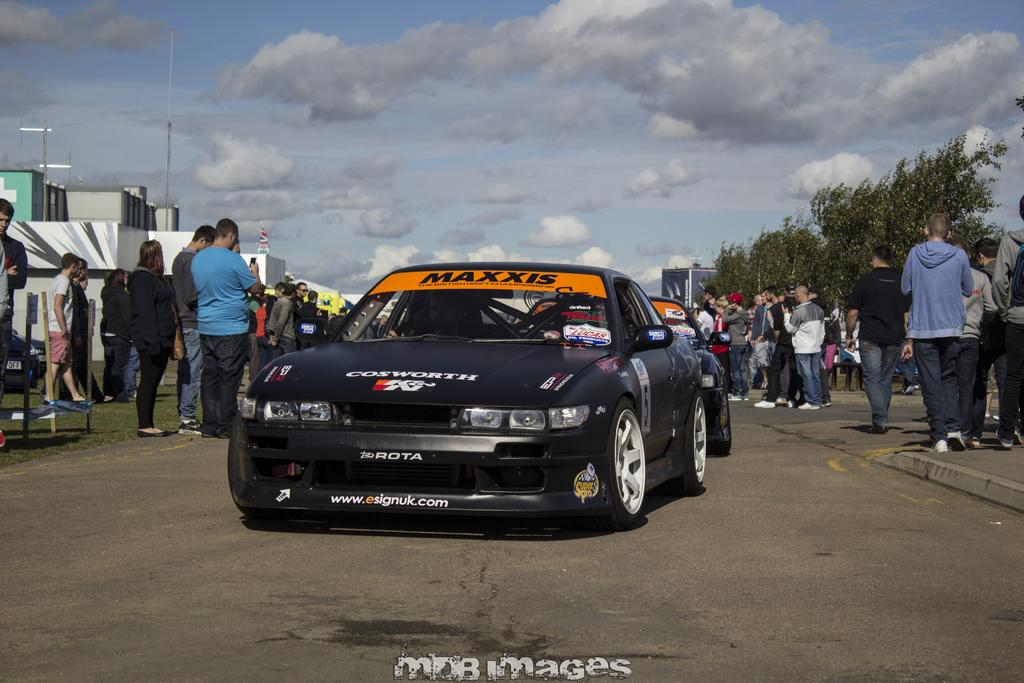What can be seen on the road in the image? There are vehicles and people on the road in the image. What is visible in the background of the image? There are buildings, trees, and the sky visible in the background of the image. Can you describe the text at the bottom of the image? Unfortunately, the provided facts do not mention the content of the text at the bottom of the image. How many bells are hanging from the trees in the image? There are no bells hanging from the trees in the image; only buildings, trees, and the sky are visible in the background. What color are the eggs in the image? There are no eggs present in the image. 